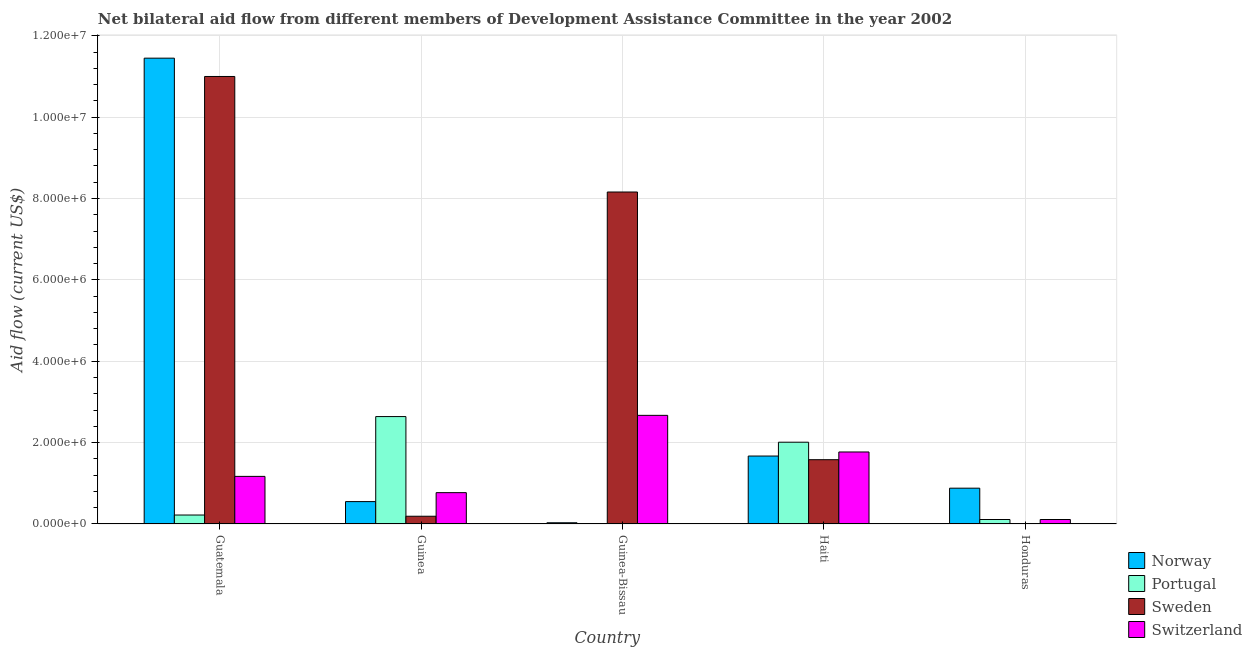How many groups of bars are there?
Provide a succinct answer. 5. How many bars are there on the 2nd tick from the left?
Offer a very short reply. 4. How many bars are there on the 4th tick from the right?
Offer a terse response. 4. What is the label of the 4th group of bars from the left?
Make the answer very short. Haiti. What is the amount of aid given by portugal in Guinea?
Give a very brief answer. 2.64e+06. Across all countries, what is the maximum amount of aid given by norway?
Give a very brief answer. 1.14e+07. Across all countries, what is the minimum amount of aid given by norway?
Provide a short and direct response. 3.00e+04. In which country was the amount of aid given by portugal maximum?
Your answer should be very brief. Guinea. In which country was the amount of aid given by sweden minimum?
Provide a short and direct response. Honduras. What is the total amount of aid given by norway in the graph?
Make the answer very short. 1.46e+07. What is the difference between the amount of aid given by portugal in Guatemala and that in Guinea-Bissau?
Your response must be concise. 2.10e+05. What is the difference between the amount of aid given by switzerland in Honduras and the amount of aid given by portugal in Guatemala?
Provide a short and direct response. -1.10e+05. What is the average amount of aid given by sweden per country?
Your answer should be compact. 4.19e+06. What is the difference between the amount of aid given by sweden and amount of aid given by portugal in Haiti?
Keep it short and to the point. -4.30e+05. What is the ratio of the amount of aid given by switzerland in Guinea-Bissau to that in Honduras?
Your answer should be very brief. 24.27. What is the difference between the highest and the second highest amount of aid given by sweden?
Keep it short and to the point. 2.84e+06. What is the difference between the highest and the lowest amount of aid given by portugal?
Your answer should be compact. 2.63e+06. In how many countries, is the amount of aid given by norway greater than the average amount of aid given by norway taken over all countries?
Keep it short and to the point. 1. Is the sum of the amount of aid given by norway in Guatemala and Haiti greater than the maximum amount of aid given by sweden across all countries?
Offer a very short reply. Yes. What does the 1st bar from the right in Guatemala represents?
Ensure brevity in your answer.  Switzerland. Are all the bars in the graph horizontal?
Offer a very short reply. No. What is the difference between two consecutive major ticks on the Y-axis?
Your answer should be very brief. 2.00e+06. Are the values on the major ticks of Y-axis written in scientific E-notation?
Provide a short and direct response. Yes. Does the graph contain any zero values?
Offer a terse response. No. Where does the legend appear in the graph?
Offer a very short reply. Bottom right. What is the title of the graph?
Provide a succinct answer. Net bilateral aid flow from different members of Development Assistance Committee in the year 2002. Does "UNPBF" appear as one of the legend labels in the graph?
Your response must be concise. No. What is the Aid flow (current US$) in Norway in Guatemala?
Give a very brief answer. 1.14e+07. What is the Aid flow (current US$) in Sweden in Guatemala?
Your answer should be compact. 1.10e+07. What is the Aid flow (current US$) of Switzerland in Guatemala?
Your answer should be compact. 1.17e+06. What is the Aid flow (current US$) of Portugal in Guinea?
Your answer should be compact. 2.64e+06. What is the Aid flow (current US$) in Switzerland in Guinea?
Make the answer very short. 7.70e+05. What is the Aid flow (current US$) in Norway in Guinea-Bissau?
Ensure brevity in your answer.  3.00e+04. What is the Aid flow (current US$) in Sweden in Guinea-Bissau?
Ensure brevity in your answer.  8.16e+06. What is the Aid flow (current US$) of Switzerland in Guinea-Bissau?
Give a very brief answer. 2.67e+06. What is the Aid flow (current US$) in Norway in Haiti?
Keep it short and to the point. 1.67e+06. What is the Aid flow (current US$) of Portugal in Haiti?
Your answer should be very brief. 2.01e+06. What is the Aid flow (current US$) of Sweden in Haiti?
Give a very brief answer. 1.58e+06. What is the Aid flow (current US$) of Switzerland in Haiti?
Make the answer very short. 1.77e+06. What is the Aid flow (current US$) of Norway in Honduras?
Give a very brief answer. 8.80e+05. What is the Aid flow (current US$) of Sweden in Honduras?
Keep it short and to the point. 10000. What is the Aid flow (current US$) in Switzerland in Honduras?
Make the answer very short. 1.10e+05. Across all countries, what is the maximum Aid flow (current US$) in Norway?
Offer a very short reply. 1.14e+07. Across all countries, what is the maximum Aid flow (current US$) in Portugal?
Ensure brevity in your answer.  2.64e+06. Across all countries, what is the maximum Aid flow (current US$) in Sweden?
Offer a very short reply. 1.10e+07. Across all countries, what is the maximum Aid flow (current US$) in Switzerland?
Your answer should be very brief. 2.67e+06. Across all countries, what is the minimum Aid flow (current US$) of Portugal?
Give a very brief answer. 10000. Across all countries, what is the minimum Aid flow (current US$) of Sweden?
Offer a very short reply. 10000. Across all countries, what is the minimum Aid flow (current US$) of Switzerland?
Your answer should be very brief. 1.10e+05. What is the total Aid flow (current US$) of Norway in the graph?
Your answer should be very brief. 1.46e+07. What is the total Aid flow (current US$) in Portugal in the graph?
Give a very brief answer. 4.99e+06. What is the total Aid flow (current US$) of Sweden in the graph?
Offer a very short reply. 2.09e+07. What is the total Aid flow (current US$) of Switzerland in the graph?
Your answer should be very brief. 6.49e+06. What is the difference between the Aid flow (current US$) in Norway in Guatemala and that in Guinea?
Your answer should be very brief. 1.09e+07. What is the difference between the Aid flow (current US$) of Portugal in Guatemala and that in Guinea?
Your response must be concise. -2.42e+06. What is the difference between the Aid flow (current US$) of Sweden in Guatemala and that in Guinea?
Your answer should be very brief. 1.08e+07. What is the difference between the Aid flow (current US$) in Switzerland in Guatemala and that in Guinea?
Give a very brief answer. 4.00e+05. What is the difference between the Aid flow (current US$) in Norway in Guatemala and that in Guinea-Bissau?
Provide a succinct answer. 1.14e+07. What is the difference between the Aid flow (current US$) of Sweden in Guatemala and that in Guinea-Bissau?
Provide a succinct answer. 2.84e+06. What is the difference between the Aid flow (current US$) of Switzerland in Guatemala and that in Guinea-Bissau?
Ensure brevity in your answer.  -1.50e+06. What is the difference between the Aid flow (current US$) in Norway in Guatemala and that in Haiti?
Provide a succinct answer. 9.78e+06. What is the difference between the Aid flow (current US$) of Portugal in Guatemala and that in Haiti?
Provide a succinct answer. -1.79e+06. What is the difference between the Aid flow (current US$) of Sweden in Guatemala and that in Haiti?
Keep it short and to the point. 9.42e+06. What is the difference between the Aid flow (current US$) in Switzerland in Guatemala and that in Haiti?
Provide a succinct answer. -6.00e+05. What is the difference between the Aid flow (current US$) in Norway in Guatemala and that in Honduras?
Keep it short and to the point. 1.06e+07. What is the difference between the Aid flow (current US$) in Portugal in Guatemala and that in Honduras?
Your answer should be very brief. 1.10e+05. What is the difference between the Aid flow (current US$) in Sweden in Guatemala and that in Honduras?
Your response must be concise. 1.10e+07. What is the difference between the Aid flow (current US$) in Switzerland in Guatemala and that in Honduras?
Offer a terse response. 1.06e+06. What is the difference between the Aid flow (current US$) in Norway in Guinea and that in Guinea-Bissau?
Keep it short and to the point. 5.20e+05. What is the difference between the Aid flow (current US$) in Portugal in Guinea and that in Guinea-Bissau?
Make the answer very short. 2.63e+06. What is the difference between the Aid flow (current US$) of Sweden in Guinea and that in Guinea-Bissau?
Make the answer very short. -7.97e+06. What is the difference between the Aid flow (current US$) in Switzerland in Guinea and that in Guinea-Bissau?
Your answer should be compact. -1.90e+06. What is the difference between the Aid flow (current US$) in Norway in Guinea and that in Haiti?
Your answer should be very brief. -1.12e+06. What is the difference between the Aid flow (current US$) in Portugal in Guinea and that in Haiti?
Your answer should be compact. 6.30e+05. What is the difference between the Aid flow (current US$) in Sweden in Guinea and that in Haiti?
Provide a short and direct response. -1.39e+06. What is the difference between the Aid flow (current US$) in Norway in Guinea and that in Honduras?
Give a very brief answer. -3.30e+05. What is the difference between the Aid flow (current US$) in Portugal in Guinea and that in Honduras?
Provide a short and direct response. 2.53e+06. What is the difference between the Aid flow (current US$) in Switzerland in Guinea and that in Honduras?
Ensure brevity in your answer.  6.60e+05. What is the difference between the Aid flow (current US$) of Norway in Guinea-Bissau and that in Haiti?
Ensure brevity in your answer.  -1.64e+06. What is the difference between the Aid flow (current US$) of Portugal in Guinea-Bissau and that in Haiti?
Provide a succinct answer. -2.00e+06. What is the difference between the Aid flow (current US$) of Sweden in Guinea-Bissau and that in Haiti?
Ensure brevity in your answer.  6.58e+06. What is the difference between the Aid flow (current US$) of Norway in Guinea-Bissau and that in Honduras?
Your response must be concise. -8.50e+05. What is the difference between the Aid flow (current US$) of Portugal in Guinea-Bissau and that in Honduras?
Offer a very short reply. -1.00e+05. What is the difference between the Aid flow (current US$) of Sweden in Guinea-Bissau and that in Honduras?
Ensure brevity in your answer.  8.15e+06. What is the difference between the Aid flow (current US$) in Switzerland in Guinea-Bissau and that in Honduras?
Provide a succinct answer. 2.56e+06. What is the difference between the Aid flow (current US$) of Norway in Haiti and that in Honduras?
Provide a succinct answer. 7.90e+05. What is the difference between the Aid flow (current US$) of Portugal in Haiti and that in Honduras?
Give a very brief answer. 1.90e+06. What is the difference between the Aid flow (current US$) in Sweden in Haiti and that in Honduras?
Give a very brief answer. 1.57e+06. What is the difference between the Aid flow (current US$) in Switzerland in Haiti and that in Honduras?
Offer a very short reply. 1.66e+06. What is the difference between the Aid flow (current US$) of Norway in Guatemala and the Aid flow (current US$) of Portugal in Guinea?
Keep it short and to the point. 8.81e+06. What is the difference between the Aid flow (current US$) in Norway in Guatemala and the Aid flow (current US$) in Sweden in Guinea?
Offer a very short reply. 1.13e+07. What is the difference between the Aid flow (current US$) of Norway in Guatemala and the Aid flow (current US$) of Switzerland in Guinea?
Give a very brief answer. 1.07e+07. What is the difference between the Aid flow (current US$) of Portugal in Guatemala and the Aid flow (current US$) of Switzerland in Guinea?
Make the answer very short. -5.50e+05. What is the difference between the Aid flow (current US$) of Sweden in Guatemala and the Aid flow (current US$) of Switzerland in Guinea?
Provide a succinct answer. 1.02e+07. What is the difference between the Aid flow (current US$) of Norway in Guatemala and the Aid flow (current US$) of Portugal in Guinea-Bissau?
Your answer should be very brief. 1.14e+07. What is the difference between the Aid flow (current US$) of Norway in Guatemala and the Aid flow (current US$) of Sweden in Guinea-Bissau?
Give a very brief answer. 3.29e+06. What is the difference between the Aid flow (current US$) of Norway in Guatemala and the Aid flow (current US$) of Switzerland in Guinea-Bissau?
Your answer should be very brief. 8.78e+06. What is the difference between the Aid flow (current US$) in Portugal in Guatemala and the Aid flow (current US$) in Sweden in Guinea-Bissau?
Provide a short and direct response. -7.94e+06. What is the difference between the Aid flow (current US$) of Portugal in Guatemala and the Aid flow (current US$) of Switzerland in Guinea-Bissau?
Offer a terse response. -2.45e+06. What is the difference between the Aid flow (current US$) of Sweden in Guatemala and the Aid flow (current US$) of Switzerland in Guinea-Bissau?
Provide a succinct answer. 8.33e+06. What is the difference between the Aid flow (current US$) in Norway in Guatemala and the Aid flow (current US$) in Portugal in Haiti?
Give a very brief answer. 9.44e+06. What is the difference between the Aid flow (current US$) in Norway in Guatemala and the Aid flow (current US$) in Sweden in Haiti?
Your response must be concise. 9.87e+06. What is the difference between the Aid flow (current US$) in Norway in Guatemala and the Aid flow (current US$) in Switzerland in Haiti?
Offer a very short reply. 9.68e+06. What is the difference between the Aid flow (current US$) in Portugal in Guatemala and the Aid flow (current US$) in Sweden in Haiti?
Provide a succinct answer. -1.36e+06. What is the difference between the Aid flow (current US$) in Portugal in Guatemala and the Aid flow (current US$) in Switzerland in Haiti?
Provide a succinct answer. -1.55e+06. What is the difference between the Aid flow (current US$) in Sweden in Guatemala and the Aid flow (current US$) in Switzerland in Haiti?
Keep it short and to the point. 9.23e+06. What is the difference between the Aid flow (current US$) of Norway in Guatemala and the Aid flow (current US$) of Portugal in Honduras?
Give a very brief answer. 1.13e+07. What is the difference between the Aid flow (current US$) of Norway in Guatemala and the Aid flow (current US$) of Sweden in Honduras?
Keep it short and to the point. 1.14e+07. What is the difference between the Aid flow (current US$) of Norway in Guatemala and the Aid flow (current US$) of Switzerland in Honduras?
Your answer should be very brief. 1.13e+07. What is the difference between the Aid flow (current US$) of Sweden in Guatemala and the Aid flow (current US$) of Switzerland in Honduras?
Give a very brief answer. 1.09e+07. What is the difference between the Aid flow (current US$) of Norway in Guinea and the Aid flow (current US$) of Portugal in Guinea-Bissau?
Provide a succinct answer. 5.40e+05. What is the difference between the Aid flow (current US$) of Norway in Guinea and the Aid flow (current US$) of Sweden in Guinea-Bissau?
Provide a succinct answer. -7.61e+06. What is the difference between the Aid flow (current US$) of Norway in Guinea and the Aid flow (current US$) of Switzerland in Guinea-Bissau?
Offer a very short reply. -2.12e+06. What is the difference between the Aid flow (current US$) in Portugal in Guinea and the Aid flow (current US$) in Sweden in Guinea-Bissau?
Your response must be concise. -5.52e+06. What is the difference between the Aid flow (current US$) of Sweden in Guinea and the Aid flow (current US$) of Switzerland in Guinea-Bissau?
Provide a short and direct response. -2.48e+06. What is the difference between the Aid flow (current US$) of Norway in Guinea and the Aid flow (current US$) of Portugal in Haiti?
Your response must be concise. -1.46e+06. What is the difference between the Aid flow (current US$) in Norway in Guinea and the Aid flow (current US$) in Sweden in Haiti?
Offer a very short reply. -1.03e+06. What is the difference between the Aid flow (current US$) of Norway in Guinea and the Aid flow (current US$) of Switzerland in Haiti?
Give a very brief answer. -1.22e+06. What is the difference between the Aid flow (current US$) in Portugal in Guinea and the Aid flow (current US$) in Sweden in Haiti?
Provide a succinct answer. 1.06e+06. What is the difference between the Aid flow (current US$) of Portugal in Guinea and the Aid flow (current US$) of Switzerland in Haiti?
Give a very brief answer. 8.70e+05. What is the difference between the Aid flow (current US$) in Sweden in Guinea and the Aid flow (current US$) in Switzerland in Haiti?
Keep it short and to the point. -1.58e+06. What is the difference between the Aid flow (current US$) in Norway in Guinea and the Aid flow (current US$) in Portugal in Honduras?
Your response must be concise. 4.40e+05. What is the difference between the Aid flow (current US$) in Norway in Guinea and the Aid flow (current US$) in Sweden in Honduras?
Your answer should be very brief. 5.40e+05. What is the difference between the Aid flow (current US$) of Portugal in Guinea and the Aid flow (current US$) of Sweden in Honduras?
Provide a succinct answer. 2.63e+06. What is the difference between the Aid flow (current US$) in Portugal in Guinea and the Aid flow (current US$) in Switzerland in Honduras?
Offer a very short reply. 2.53e+06. What is the difference between the Aid flow (current US$) of Sweden in Guinea and the Aid flow (current US$) of Switzerland in Honduras?
Keep it short and to the point. 8.00e+04. What is the difference between the Aid flow (current US$) of Norway in Guinea-Bissau and the Aid flow (current US$) of Portugal in Haiti?
Your response must be concise. -1.98e+06. What is the difference between the Aid flow (current US$) of Norway in Guinea-Bissau and the Aid flow (current US$) of Sweden in Haiti?
Provide a succinct answer. -1.55e+06. What is the difference between the Aid flow (current US$) in Norway in Guinea-Bissau and the Aid flow (current US$) in Switzerland in Haiti?
Provide a succinct answer. -1.74e+06. What is the difference between the Aid flow (current US$) in Portugal in Guinea-Bissau and the Aid flow (current US$) in Sweden in Haiti?
Your answer should be compact. -1.57e+06. What is the difference between the Aid flow (current US$) of Portugal in Guinea-Bissau and the Aid flow (current US$) of Switzerland in Haiti?
Your answer should be compact. -1.76e+06. What is the difference between the Aid flow (current US$) in Sweden in Guinea-Bissau and the Aid flow (current US$) in Switzerland in Haiti?
Give a very brief answer. 6.39e+06. What is the difference between the Aid flow (current US$) of Norway in Guinea-Bissau and the Aid flow (current US$) of Portugal in Honduras?
Make the answer very short. -8.00e+04. What is the difference between the Aid flow (current US$) in Portugal in Guinea-Bissau and the Aid flow (current US$) in Sweden in Honduras?
Offer a terse response. 0. What is the difference between the Aid flow (current US$) of Portugal in Guinea-Bissau and the Aid flow (current US$) of Switzerland in Honduras?
Provide a succinct answer. -1.00e+05. What is the difference between the Aid flow (current US$) in Sweden in Guinea-Bissau and the Aid flow (current US$) in Switzerland in Honduras?
Your answer should be very brief. 8.05e+06. What is the difference between the Aid flow (current US$) in Norway in Haiti and the Aid flow (current US$) in Portugal in Honduras?
Your answer should be compact. 1.56e+06. What is the difference between the Aid flow (current US$) of Norway in Haiti and the Aid flow (current US$) of Sweden in Honduras?
Offer a terse response. 1.66e+06. What is the difference between the Aid flow (current US$) in Norway in Haiti and the Aid flow (current US$) in Switzerland in Honduras?
Ensure brevity in your answer.  1.56e+06. What is the difference between the Aid flow (current US$) in Portugal in Haiti and the Aid flow (current US$) in Sweden in Honduras?
Your response must be concise. 2.00e+06. What is the difference between the Aid flow (current US$) of Portugal in Haiti and the Aid flow (current US$) of Switzerland in Honduras?
Make the answer very short. 1.90e+06. What is the difference between the Aid flow (current US$) in Sweden in Haiti and the Aid flow (current US$) in Switzerland in Honduras?
Your answer should be very brief. 1.47e+06. What is the average Aid flow (current US$) of Norway per country?
Make the answer very short. 2.92e+06. What is the average Aid flow (current US$) of Portugal per country?
Your answer should be compact. 9.98e+05. What is the average Aid flow (current US$) in Sweden per country?
Offer a very short reply. 4.19e+06. What is the average Aid flow (current US$) in Switzerland per country?
Provide a short and direct response. 1.30e+06. What is the difference between the Aid flow (current US$) in Norway and Aid flow (current US$) in Portugal in Guatemala?
Make the answer very short. 1.12e+07. What is the difference between the Aid flow (current US$) in Norway and Aid flow (current US$) in Switzerland in Guatemala?
Offer a very short reply. 1.03e+07. What is the difference between the Aid flow (current US$) of Portugal and Aid flow (current US$) of Sweden in Guatemala?
Your response must be concise. -1.08e+07. What is the difference between the Aid flow (current US$) in Portugal and Aid flow (current US$) in Switzerland in Guatemala?
Your answer should be compact. -9.50e+05. What is the difference between the Aid flow (current US$) in Sweden and Aid flow (current US$) in Switzerland in Guatemala?
Provide a succinct answer. 9.83e+06. What is the difference between the Aid flow (current US$) in Norway and Aid flow (current US$) in Portugal in Guinea?
Offer a terse response. -2.09e+06. What is the difference between the Aid flow (current US$) of Norway and Aid flow (current US$) of Sweden in Guinea?
Make the answer very short. 3.60e+05. What is the difference between the Aid flow (current US$) of Portugal and Aid flow (current US$) of Sweden in Guinea?
Offer a very short reply. 2.45e+06. What is the difference between the Aid flow (current US$) in Portugal and Aid flow (current US$) in Switzerland in Guinea?
Your response must be concise. 1.87e+06. What is the difference between the Aid flow (current US$) in Sweden and Aid flow (current US$) in Switzerland in Guinea?
Your response must be concise. -5.80e+05. What is the difference between the Aid flow (current US$) of Norway and Aid flow (current US$) of Sweden in Guinea-Bissau?
Offer a terse response. -8.13e+06. What is the difference between the Aid flow (current US$) of Norway and Aid flow (current US$) of Switzerland in Guinea-Bissau?
Make the answer very short. -2.64e+06. What is the difference between the Aid flow (current US$) in Portugal and Aid flow (current US$) in Sweden in Guinea-Bissau?
Make the answer very short. -8.15e+06. What is the difference between the Aid flow (current US$) in Portugal and Aid flow (current US$) in Switzerland in Guinea-Bissau?
Your answer should be very brief. -2.66e+06. What is the difference between the Aid flow (current US$) of Sweden and Aid flow (current US$) of Switzerland in Guinea-Bissau?
Offer a very short reply. 5.49e+06. What is the difference between the Aid flow (current US$) in Norway and Aid flow (current US$) in Portugal in Haiti?
Offer a very short reply. -3.40e+05. What is the difference between the Aid flow (current US$) of Norway and Aid flow (current US$) of Sweden in Haiti?
Provide a succinct answer. 9.00e+04. What is the difference between the Aid flow (current US$) in Norway and Aid flow (current US$) in Switzerland in Haiti?
Make the answer very short. -1.00e+05. What is the difference between the Aid flow (current US$) in Portugal and Aid flow (current US$) in Sweden in Haiti?
Your answer should be very brief. 4.30e+05. What is the difference between the Aid flow (current US$) of Sweden and Aid flow (current US$) of Switzerland in Haiti?
Offer a terse response. -1.90e+05. What is the difference between the Aid flow (current US$) of Norway and Aid flow (current US$) of Portugal in Honduras?
Give a very brief answer. 7.70e+05. What is the difference between the Aid flow (current US$) of Norway and Aid flow (current US$) of Sweden in Honduras?
Your answer should be very brief. 8.70e+05. What is the difference between the Aid flow (current US$) of Norway and Aid flow (current US$) of Switzerland in Honduras?
Ensure brevity in your answer.  7.70e+05. What is the difference between the Aid flow (current US$) of Portugal and Aid flow (current US$) of Switzerland in Honduras?
Your response must be concise. 0. What is the difference between the Aid flow (current US$) in Sweden and Aid flow (current US$) in Switzerland in Honduras?
Offer a very short reply. -1.00e+05. What is the ratio of the Aid flow (current US$) of Norway in Guatemala to that in Guinea?
Offer a terse response. 20.82. What is the ratio of the Aid flow (current US$) of Portugal in Guatemala to that in Guinea?
Your answer should be compact. 0.08. What is the ratio of the Aid flow (current US$) of Sweden in Guatemala to that in Guinea?
Provide a succinct answer. 57.89. What is the ratio of the Aid flow (current US$) in Switzerland in Guatemala to that in Guinea?
Provide a succinct answer. 1.52. What is the ratio of the Aid flow (current US$) in Norway in Guatemala to that in Guinea-Bissau?
Ensure brevity in your answer.  381.67. What is the ratio of the Aid flow (current US$) in Portugal in Guatemala to that in Guinea-Bissau?
Offer a terse response. 22. What is the ratio of the Aid flow (current US$) of Sweden in Guatemala to that in Guinea-Bissau?
Give a very brief answer. 1.35. What is the ratio of the Aid flow (current US$) in Switzerland in Guatemala to that in Guinea-Bissau?
Keep it short and to the point. 0.44. What is the ratio of the Aid flow (current US$) of Norway in Guatemala to that in Haiti?
Your response must be concise. 6.86. What is the ratio of the Aid flow (current US$) in Portugal in Guatemala to that in Haiti?
Keep it short and to the point. 0.11. What is the ratio of the Aid flow (current US$) in Sweden in Guatemala to that in Haiti?
Ensure brevity in your answer.  6.96. What is the ratio of the Aid flow (current US$) of Switzerland in Guatemala to that in Haiti?
Ensure brevity in your answer.  0.66. What is the ratio of the Aid flow (current US$) in Norway in Guatemala to that in Honduras?
Your answer should be compact. 13.01. What is the ratio of the Aid flow (current US$) in Portugal in Guatemala to that in Honduras?
Provide a short and direct response. 2. What is the ratio of the Aid flow (current US$) of Sweden in Guatemala to that in Honduras?
Your response must be concise. 1100. What is the ratio of the Aid flow (current US$) of Switzerland in Guatemala to that in Honduras?
Offer a terse response. 10.64. What is the ratio of the Aid flow (current US$) of Norway in Guinea to that in Guinea-Bissau?
Keep it short and to the point. 18.33. What is the ratio of the Aid flow (current US$) of Portugal in Guinea to that in Guinea-Bissau?
Provide a short and direct response. 264. What is the ratio of the Aid flow (current US$) in Sweden in Guinea to that in Guinea-Bissau?
Provide a short and direct response. 0.02. What is the ratio of the Aid flow (current US$) of Switzerland in Guinea to that in Guinea-Bissau?
Offer a very short reply. 0.29. What is the ratio of the Aid flow (current US$) of Norway in Guinea to that in Haiti?
Give a very brief answer. 0.33. What is the ratio of the Aid flow (current US$) of Portugal in Guinea to that in Haiti?
Give a very brief answer. 1.31. What is the ratio of the Aid flow (current US$) of Sweden in Guinea to that in Haiti?
Keep it short and to the point. 0.12. What is the ratio of the Aid flow (current US$) of Switzerland in Guinea to that in Haiti?
Ensure brevity in your answer.  0.43. What is the ratio of the Aid flow (current US$) in Sweden in Guinea to that in Honduras?
Provide a short and direct response. 19. What is the ratio of the Aid flow (current US$) of Norway in Guinea-Bissau to that in Haiti?
Your answer should be very brief. 0.02. What is the ratio of the Aid flow (current US$) in Portugal in Guinea-Bissau to that in Haiti?
Provide a succinct answer. 0.01. What is the ratio of the Aid flow (current US$) in Sweden in Guinea-Bissau to that in Haiti?
Ensure brevity in your answer.  5.16. What is the ratio of the Aid flow (current US$) in Switzerland in Guinea-Bissau to that in Haiti?
Offer a terse response. 1.51. What is the ratio of the Aid flow (current US$) in Norway in Guinea-Bissau to that in Honduras?
Keep it short and to the point. 0.03. What is the ratio of the Aid flow (current US$) in Portugal in Guinea-Bissau to that in Honduras?
Provide a short and direct response. 0.09. What is the ratio of the Aid flow (current US$) in Sweden in Guinea-Bissau to that in Honduras?
Your response must be concise. 816. What is the ratio of the Aid flow (current US$) in Switzerland in Guinea-Bissau to that in Honduras?
Keep it short and to the point. 24.27. What is the ratio of the Aid flow (current US$) in Norway in Haiti to that in Honduras?
Offer a very short reply. 1.9. What is the ratio of the Aid flow (current US$) of Portugal in Haiti to that in Honduras?
Make the answer very short. 18.27. What is the ratio of the Aid flow (current US$) of Sweden in Haiti to that in Honduras?
Offer a terse response. 158. What is the ratio of the Aid flow (current US$) in Switzerland in Haiti to that in Honduras?
Your answer should be very brief. 16.09. What is the difference between the highest and the second highest Aid flow (current US$) of Norway?
Make the answer very short. 9.78e+06. What is the difference between the highest and the second highest Aid flow (current US$) in Portugal?
Provide a succinct answer. 6.30e+05. What is the difference between the highest and the second highest Aid flow (current US$) of Sweden?
Offer a very short reply. 2.84e+06. What is the difference between the highest and the second highest Aid flow (current US$) of Switzerland?
Offer a terse response. 9.00e+05. What is the difference between the highest and the lowest Aid flow (current US$) in Norway?
Your response must be concise. 1.14e+07. What is the difference between the highest and the lowest Aid flow (current US$) in Portugal?
Ensure brevity in your answer.  2.63e+06. What is the difference between the highest and the lowest Aid flow (current US$) of Sweden?
Offer a terse response. 1.10e+07. What is the difference between the highest and the lowest Aid flow (current US$) of Switzerland?
Your answer should be very brief. 2.56e+06. 